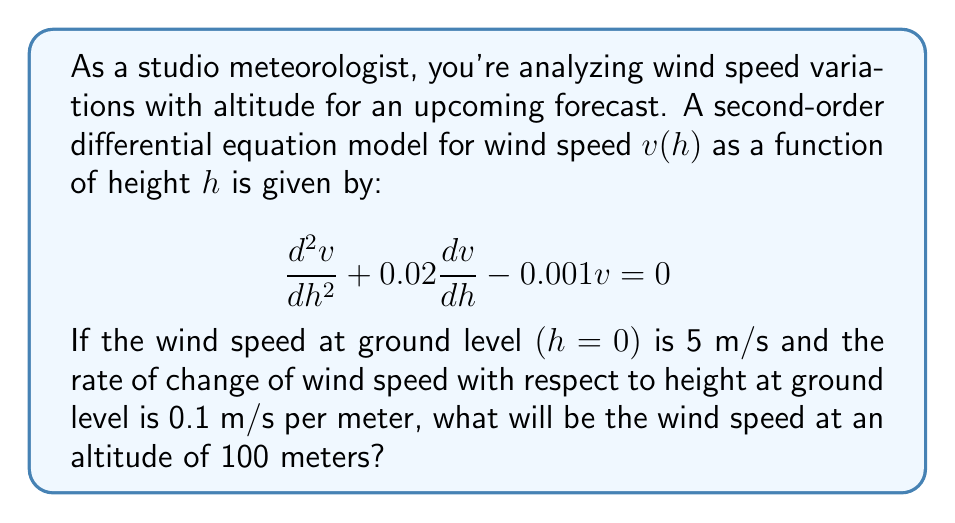Can you solve this math problem? To solve this problem, we need to follow these steps:

1) First, we identify the given differential equation and initial conditions:
   
   Differential equation: $\frac{d^2v}{dh^2} + 0.02\frac{dv}{dh} - 0.001v = 0$
   Initial conditions: $v(0) = 5$ and $v'(0) = 0.1$

2) The general solution for this second-order linear differential equation with constant coefficients is of the form:

   $v(h) = C_1e^{r_1h} + C_2e^{r_2h}$

   where $r_1$ and $r_2$ are the roots of the characteristic equation.

3) The characteristic equation is:
   
   $r^2 + 0.02r - 0.001 = 0$

4) Solving this quadratic equation:
   
   $r = \frac{-0.02 \pm \sqrt{0.02^2 + 4(0.001)}}{2} = -0.01 \pm 0.0316228$

   So, $r_1 \approx 0.0216228$ and $r_2 \approx -0.0416228$

5) Therefore, the general solution is:

   $v(h) = C_1e^{0.0216228h} + C_2e^{-0.0416228h}$

6) Using the initial conditions to find $C_1$ and $C_2$:

   $v(0) = C_1 + C_2 = 5$
   $v'(0) = 0.0216228C_1 - 0.0416228C_2 = 0.1$

7) Solving these equations:

   $C_1 \approx 3.7655$ and $C_2 \approx 1.2345$

8) So, the particular solution is:

   $v(h) = 3.7655e^{0.0216228h} + 1.2345e^{-0.0416228h}$

9) To find the wind speed at 100 meters, we evaluate $v(100)$:

   $v(100) = 3.7655e^{0.0216228(100)} + 1.2345e^{-0.0416228(100)}$
           $\approx 3.7655(8.9352) + 1.2345(0.0148)$
           $\approx 33.6447 + 0.0183$
           $\approx 33.66$ m/s
Answer: The wind speed at an altitude of 100 meters will be approximately 33.66 m/s. 